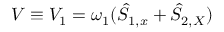Convert formula to latex. <formula><loc_0><loc_0><loc_500><loc_500>V \equiv V _ { 1 } = \omega _ { 1 } ( \hat { S } _ { 1 , x } + \hat { S } _ { 2 , X } )</formula> 